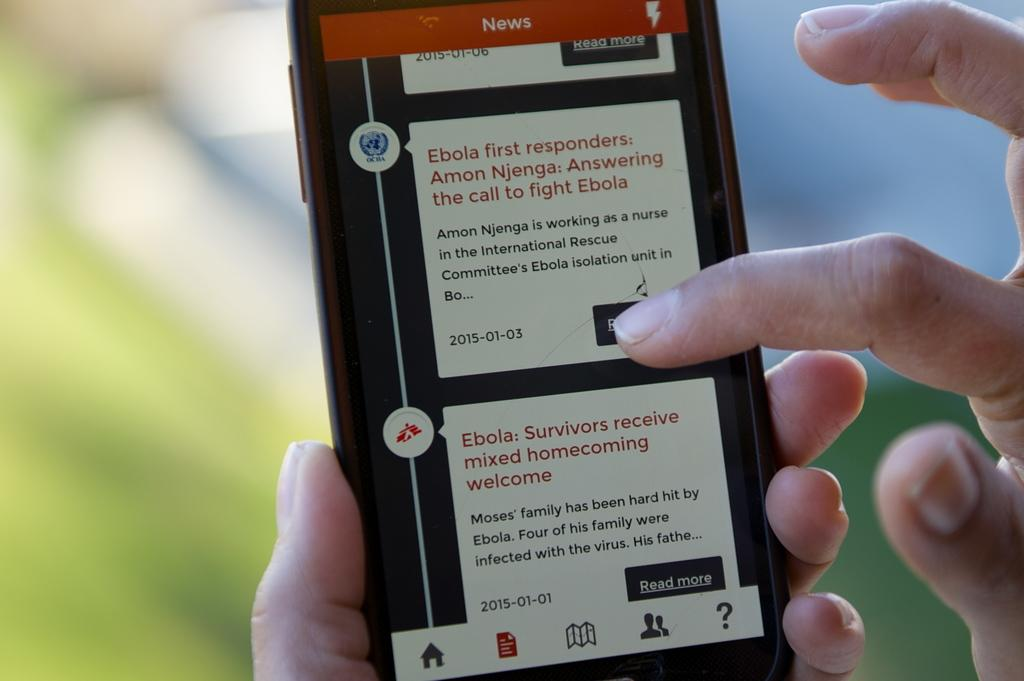<image>
Summarize the visual content of the image. a phone screen open to a page that is titled 'news' 